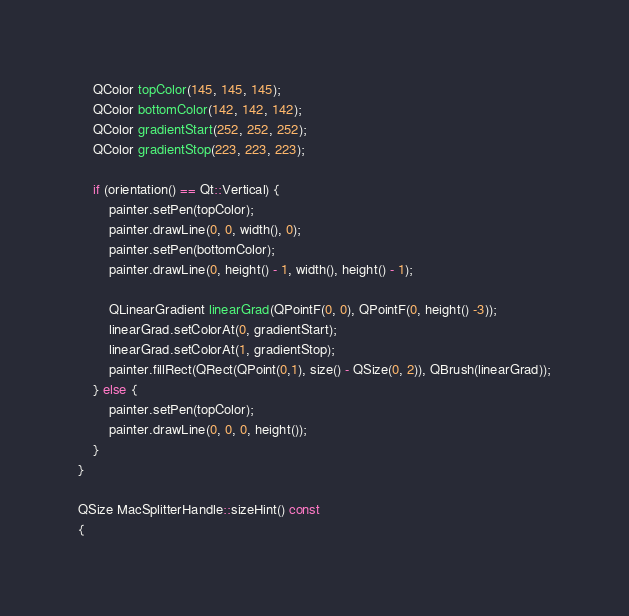<code> <loc_0><loc_0><loc_500><loc_500><_ObjectiveC_>    QColor topColor(145, 145, 145);
    QColor bottomColor(142, 142, 142);
    QColor gradientStart(252, 252, 252);
    QColor gradientStop(223, 223, 223);

    if (orientation() == Qt::Vertical) {
        painter.setPen(topColor);
        painter.drawLine(0, 0, width(), 0);
        painter.setPen(bottomColor);
        painter.drawLine(0, height() - 1, width(), height() - 1);

        QLinearGradient linearGrad(QPointF(0, 0), QPointF(0, height() -3));
        linearGrad.setColorAt(0, gradientStart);
        linearGrad.setColorAt(1, gradientStop);
        painter.fillRect(QRect(QPoint(0,1), size() - QSize(0, 2)), QBrush(linearGrad));
    } else {
        painter.setPen(topColor);
        painter.drawLine(0, 0, 0, height());
    }
}

QSize MacSplitterHandle::sizeHint() const
{</code> 